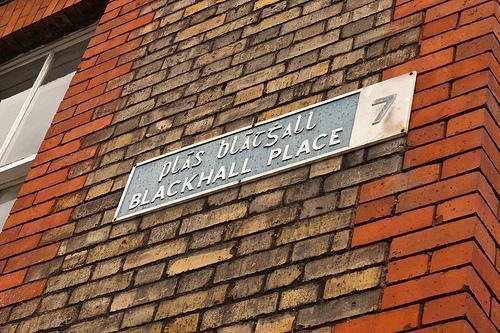How many of the characters are numbers?
Give a very brief answer. 1. 